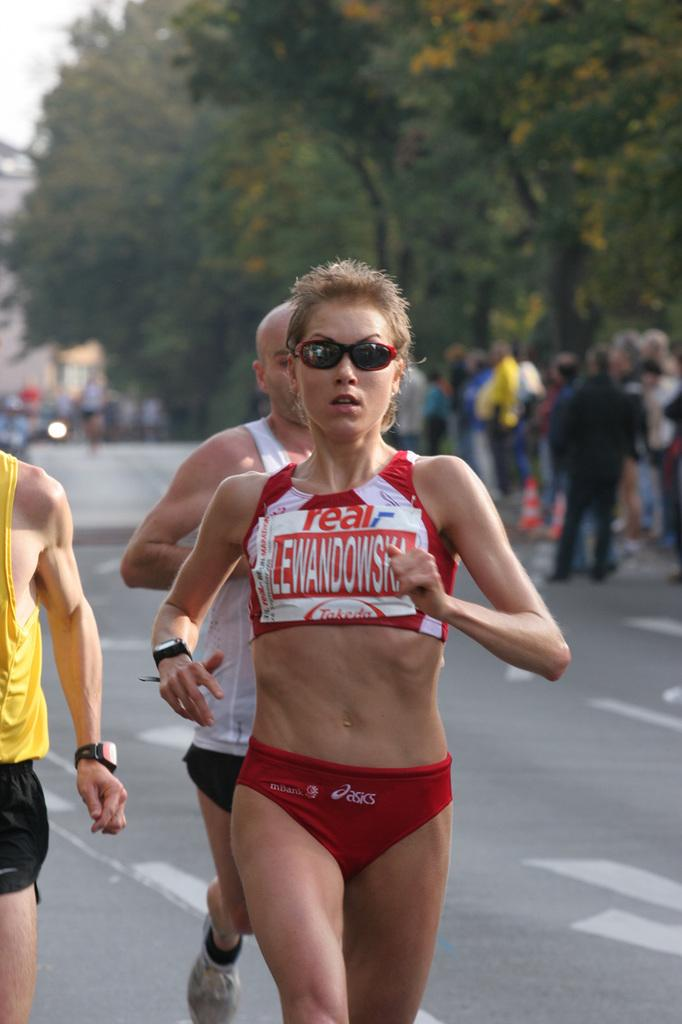Provide a one-sentence caption for the provided image. A runner in a pair of asics shorts wears sunglasses and a watch. 